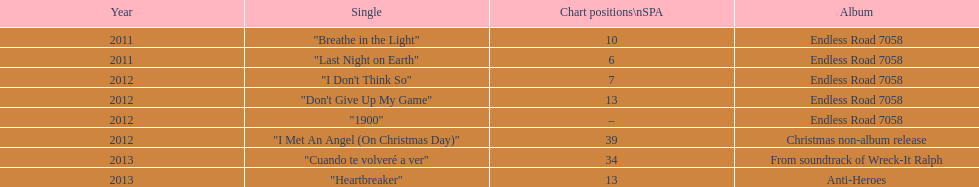Based on sales figures, what auryn album is the most popular? Endless Road 7058. 